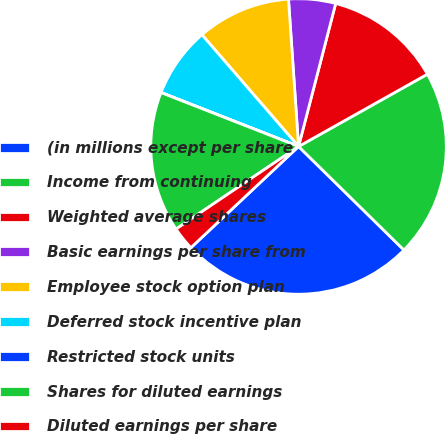<chart> <loc_0><loc_0><loc_500><loc_500><pie_chart><fcel>(in millions except per share<fcel>Income from continuing<fcel>Weighted average shares<fcel>Basic earnings per share from<fcel>Employee stock option plan<fcel>Deferred stock incentive plan<fcel>Restricted stock units<fcel>Shares for diluted earnings<fcel>Diluted earnings per share<nl><fcel>25.63%<fcel>20.5%<fcel>12.82%<fcel>5.13%<fcel>10.26%<fcel>7.7%<fcel>0.01%<fcel>15.38%<fcel>2.57%<nl></chart> 